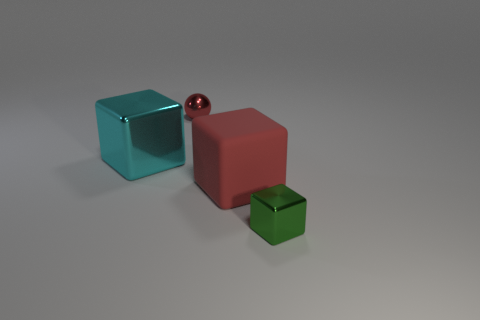Subtract 1 cubes. How many cubes are left? 2 Add 1 blue matte things. How many objects exist? 5 Subtract all balls. How many objects are left? 3 Subtract all large cyan metal things. Subtract all metallic balls. How many objects are left? 2 Add 3 green blocks. How many green blocks are left? 4 Add 4 tiny cubes. How many tiny cubes exist? 5 Subtract 0 green cylinders. How many objects are left? 4 